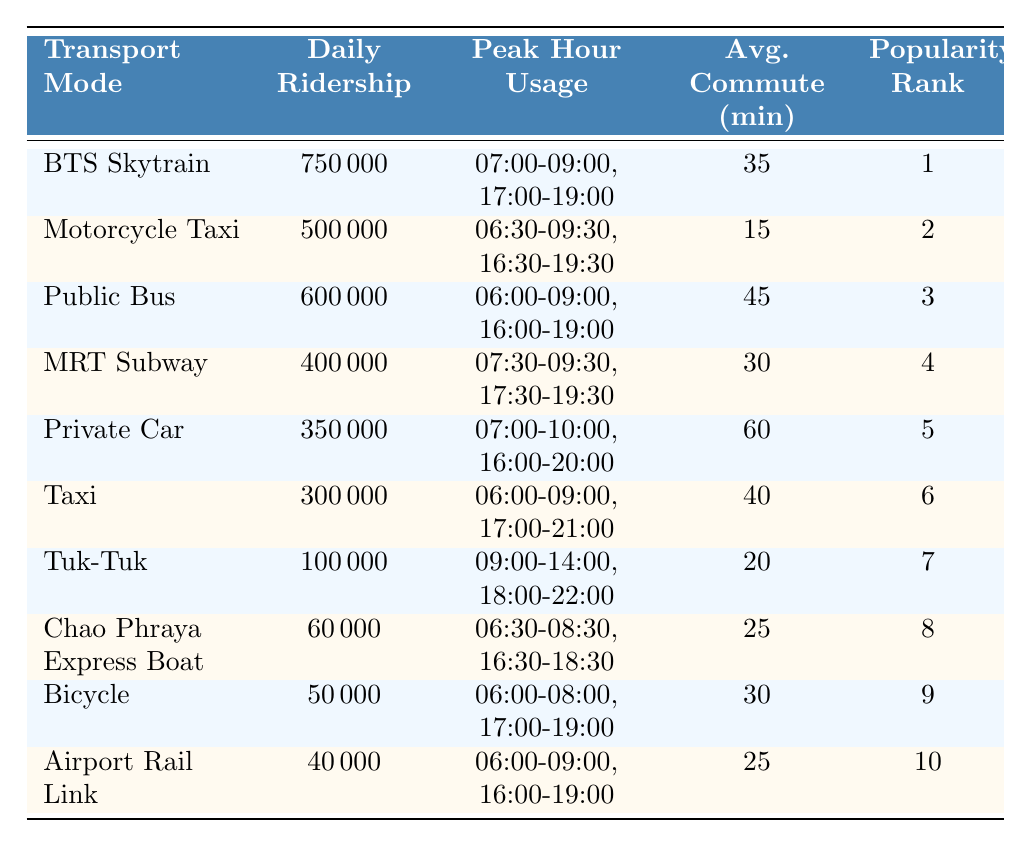What is the daily ridership of the BTS Skytrain? The table shows that the daily ridership for the BTS Skytrain is listed as 750,000.
Answer: 750,000 Which mode of transportation has the highest daily ridership? By comparing the daily ridership values in the table, the BTS Skytrain has the highest ridership at 750,000.
Answer: BTS Skytrain What is the average commute duration for the Motorcycle Taxi? The table indicates that the average commute duration for the Motorcycle Taxi is 15 minutes.
Answer: 15 minutes Which transport mode has a lower average commute duration, MRT Subway or Public Bus? The table shows that the MRT Subway has an average commute duration of 30 minutes, while the Public Bus has 45 minutes. Therefore, the MRT Subway has a lower duration.
Answer: MRT Subway How many more passengers ride the Public Bus compared to the Airport Rail Link? The daily ridership for the Public Bus is 600,000 and for the Airport Rail Link is 40,000. The difference is 600,000 - 40,000 = 560,000.
Answer: 560,000 What is the total daily ridership of the top three most popular transport modes? The daily ridership of the top three modes are: BTS Skytrain (750,000), Public Bus (600,000), and Motorcycle Taxi (500,000). Summing these gives 750,000 + 600,000 + 500,000 = 1,850,000.
Answer: 1,850,000 Is the average commute duration for taxis greater than that for private cars? The average commute duration for taxis is 40 minutes, while for private cars it is 60 minutes. Since 40 is less than 60, the statement is false.
Answer: No What time do the peak hours for the Public Bus occur? The table states that the peak hour usage for the Public Bus occurs from 06:00 to 09:00 and 16:00 to 19:00.
Answer: 06:00-09:00, 16:00-19:00 Among the transport modes listed, which one ranks 9th in popularity? According to the table, the Bicycle is ranked 9th in popularity.
Answer: Bicycle What percentage of daily ridership does the Chao Phraya Express Boat represent compared to the BTS Skytrain? The daily ridership of the Chao Phraya Express Boat is 60,000 and the BTS Skytrain is 750,000. The percentage is (60,000 / 750,000) * 100 = 8%.
Answer: 8% 